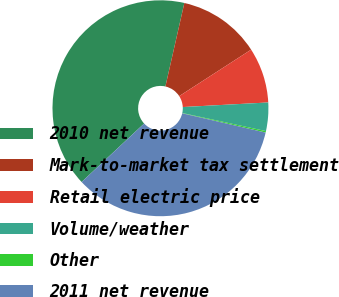<chart> <loc_0><loc_0><loc_500><loc_500><pie_chart><fcel>2010 net revenue<fcel>Mark-to-market tax settlement<fcel>Retail electric price<fcel>Volume/weather<fcel>Other<fcel>2011 net revenue<nl><fcel>40.52%<fcel>12.31%<fcel>8.28%<fcel>4.25%<fcel>0.22%<fcel>34.41%<nl></chart> 